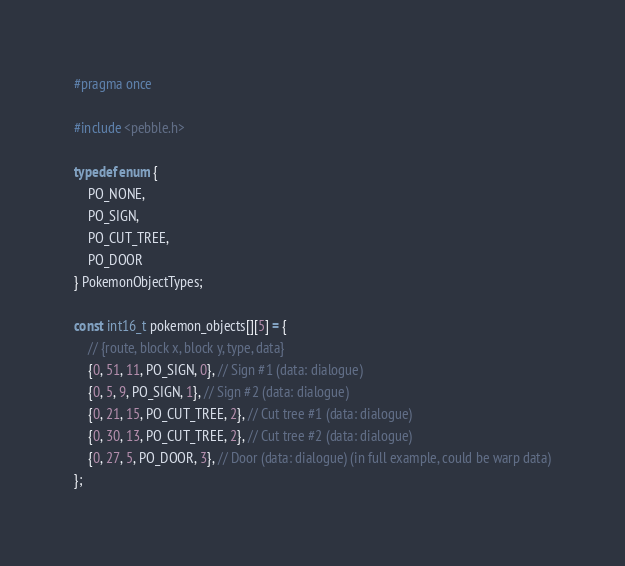<code> <loc_0><loc_0><loc_500><loc_500><_C_>#pragma once

#include <pebble.h>

typedef enum {
    PO_NONE,
    PO_SIGN,
    PO_CUT_TREE,
    PO_DOOR
} PokemonObjectTypes;

const int16_t pokemon_objects[][5] = {
    // {route, block x, block y, type, data}
    {0, 51, 11, PO_SIGN, 0}, // Sign #1 (data: dialogue)
    {0, 5, 9, PO_SIGN, 1}, // Sign #2 (data: dialogue)
    {0, 21, 15, PO_CUT_TREE, 2}, // Cut tree #1 (data: dialogue)
    {0, 30, 13, PO_CUT_TREE, 2}, // Cut tree #2 (data: dialogue)
    {0, 27, 5, PO_DOOR, 3}, // Door (data: dialogue) (in full example, could be warp data)
};

</code> 